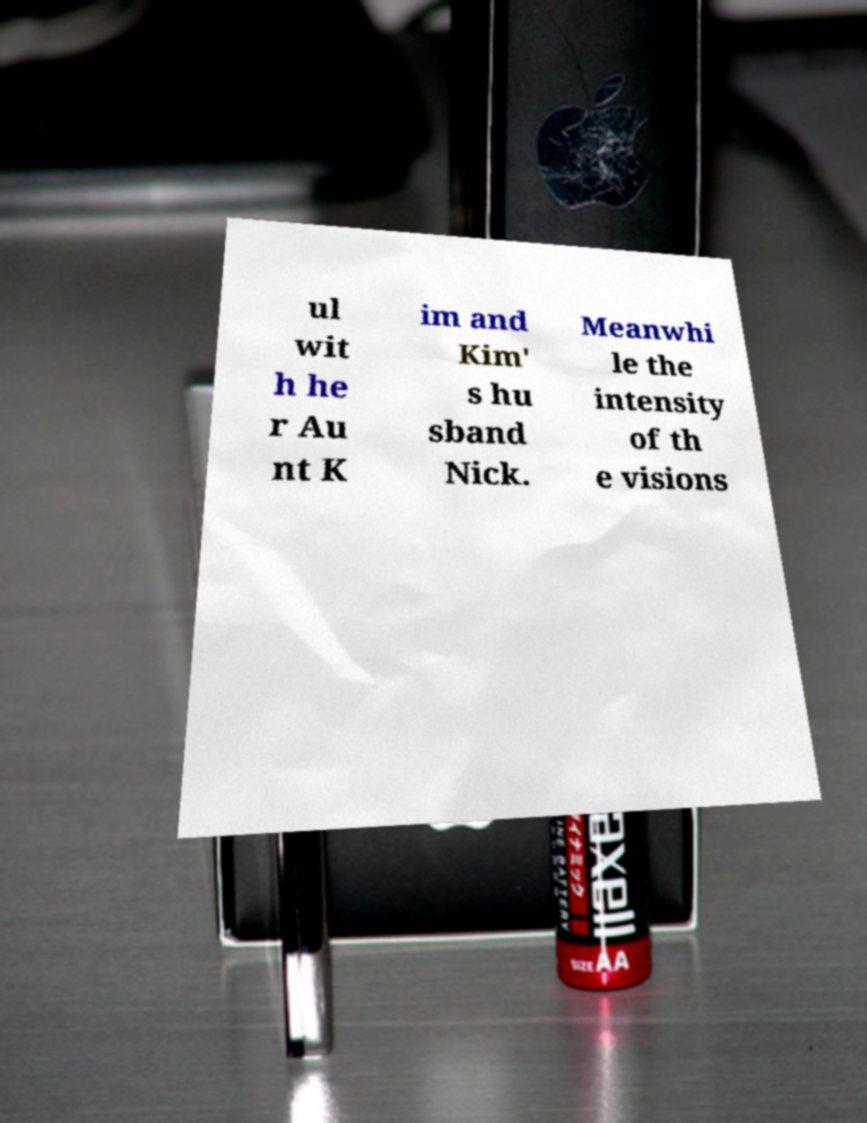There's text embedded in this image that I need extracted. Can you transcribe it verbatim? ul wit h he r Au nt K im and Kim' s hu sband Nick. Meanwhi le the intensity of th e visions 